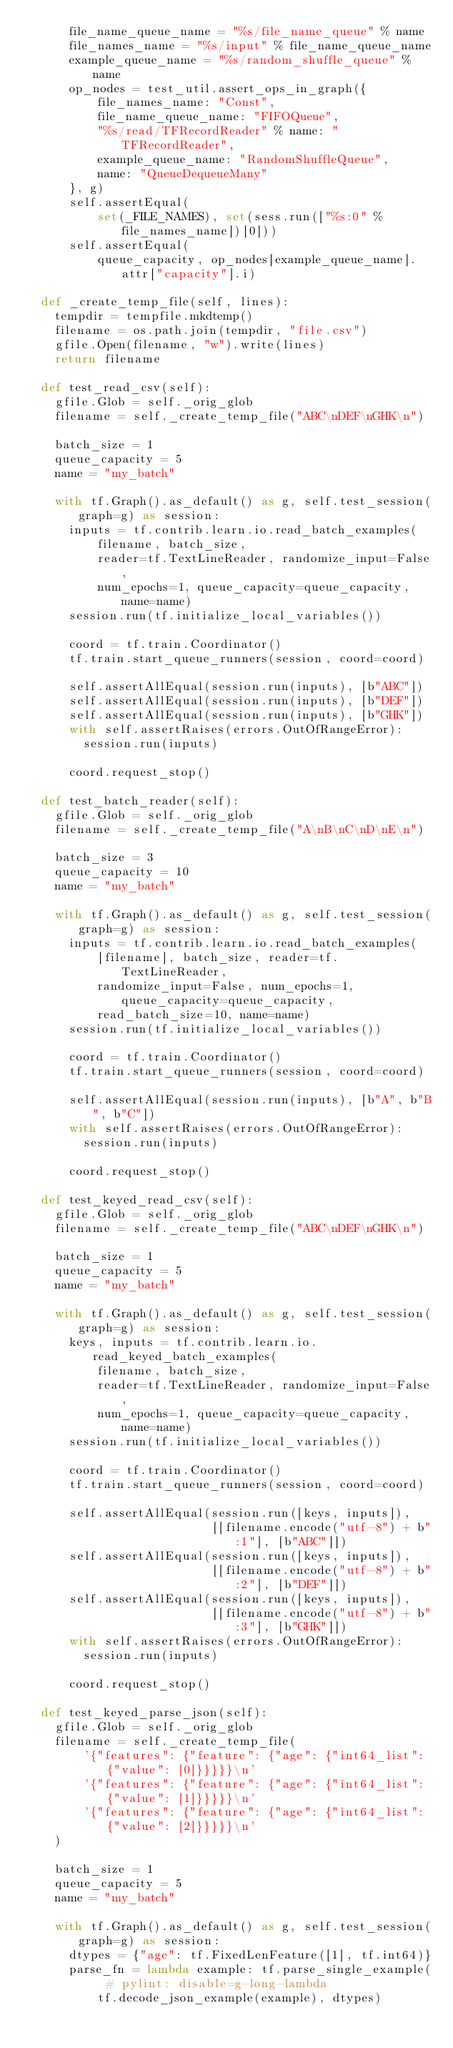<code> <loc_0><loc_0><loc_500><loc_500><_Python_>      file_name_queue_name = "%s/file_name_queue" % name
      file_names_name = "%s/input" % file_name_queue_name
      example_queue_name = "%s/random_shuffle_queue" % name
      op_nodes = test_util.assert_ops_in_graph({
          file_names_name: "Const",
          file_name_queue_name: "FIFOQueue",
          "%s/read/TFRecordReader" % name: "TFRecordReader",
          example_queue_name: "RandomShuffleQueue",
          name: "QueueDequeueMany"
      }, g)
      self.assertEqual(
          set(_FILE_NAMES), set(sess.run(["%s:0" % file_names_name])[0]))
      self.assertEqual(
          queue_capacity, op_nodes[example_queue_name].attr["capacity"].i)

  def _create_temp_file(self, lines):
    tempdir = tempfile.mkdtemp()
    filename = os.path.join(tempdir, "file.csv")
    gfile.Open(filename, "w").write(lines)
    return filename

  def test_read_csv(self):
    gfile.Glob = self._orig_glob
    filename = self._create_temp_file("ABC\nDEF\nGHK\n")

    batch_size = 1
    queue_capacity = 5
    name = "my_batch"

    with tf.Graph().as_default() as g, self.test_session(graph=g) as session:
      inputs = tf.contrib.learn.io.read_batch_examples(
          filename, batch_size,
          reader=tf.TextLineReader, randomize_input=False,
          num_epochs=1, queue_capacity=queue_capacity, name=name)
      session.run(tf.initialize_local_variables())

      coord = tf.train.Coordinator()
      tf.train.start_queue_runners(session, coord=coord)

      self.assertAllEqual(session.run(inputs), [b"ABC"])
      self.assertAllEqual(session.run(inputs), [b"DEF"])
      self.assertAllEqual(session.run(inputs), [b"GHK"])
      with self.assertRaises(errors.OutOfRangeError):
        session.run(inputs)

      coord.request_stop()

  def test_batch_reader(self):
    gfile.Glob = self._orig_glob
    filename = self._create_temp_file("A\nB\nC\nD\nE\n")

    batch_size = 3
    queue_capacity = 10
    name = "my_batch"

    with tf.Graph().as_default() as g, self.test_session(graph=g) as session:
      inputs = tf.contrib.learn.io.read_batch_examples(
          [filename], batch_size, reader=tf.TextLineReader,
          randomize_input=False, num_epochs=1, queue_capacity=queue_capacity,
          read_batch_size=10, name=name)
      session.run(tf.initialize_local_variables())

      coord = tf.train.Coordinator()
      tf.train.start_queue_runners(session, coord=coord)

      self.assertAllEqual(session.run(inputs), [b"A", b"B", b"C"])
      with self.assertRaises(errors.OutOfRangeError):
        session.run(inputs)

      coord.request_stop()

  def test_keyed_read_csv(self):
    gfile.Glob = self._orig_glob
    filename = self._create_temp_file("ABC\nDEF\nGHK\n")

    batch_size = 1
    queue_capacity = 5
    name = "my_batch"

    with tf.Graph().as_default() as g, self.test_session(graph=g) as session:
      keys, inputs = tf.contrib.learn.io.read_keyed_batch_examples(
          filename, batch_size,
          reader=tf.TextLineReader, randomize_input=False,
          num_epochs=1, queue_capacity=queue_capacity, name=name)
      session.run(tf.initialize_local_variables())

      coord = tf.train.Coordinator()
      tf.train.start_queue_runners(session, coord=coord)

      self.assertAllEqual(session.run([keys, inputs]),
                          [[filename.encode("utf-8") + b":1"], [b"ABC"]])
      self.assertAllEqual(session.run([keys, inputs]),
                          [[filename.encode("utf-8") + b":2"], [b"DEF"]])
      self.assertAllEqual(session.run([keys, inputs]),
                          [[filename.encode("utf-8") + b":3"], [b"GHK"]])
      with self.assertRaises(errors.OutOfRangeError):
        session.run(inputs)

      coord.request_stop()

  def test_keyed_parse_json(self):
    gfile.Glob = self._orig_glob
    filename = self._create_temp_file(
        '{"features": {"feature": {"age": {"int64_list": {"value": [0]}}}}}\n'
        '{"features": {"feature": {"age": {"int64_list": {"value": [1]}}}}}\n'
        '{"features": {"feature": {"age": {"int64_list": {"value": [2]}}}}}\n'
    )

    batch_size = 1
    queue_capacity = 5
    name = "my_batch"

    with tf.Graph().as_default() as g, self.test_session(graph=g) as session:
      dtypes = {"age": tf.FixedLenFeature([1], tf.int64)}
      parse_fn = lambda example: tf.parse_single_example(  # pylint: disable=g-long-lambda
          tf.decode_json_example(example), dtypes)</code> 